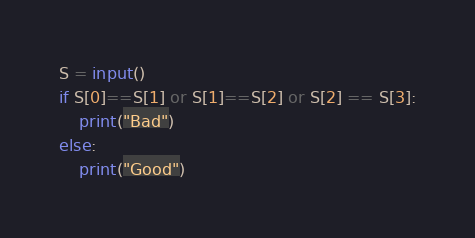<code> <loc_0><loc_0><loc_500><loc_500><_Python_>
S = input()
if S[0]==S[1] or S[1]==S[2] or S[2] == S[3]:
	print("Bad")
else:
	print("Good")</code> 